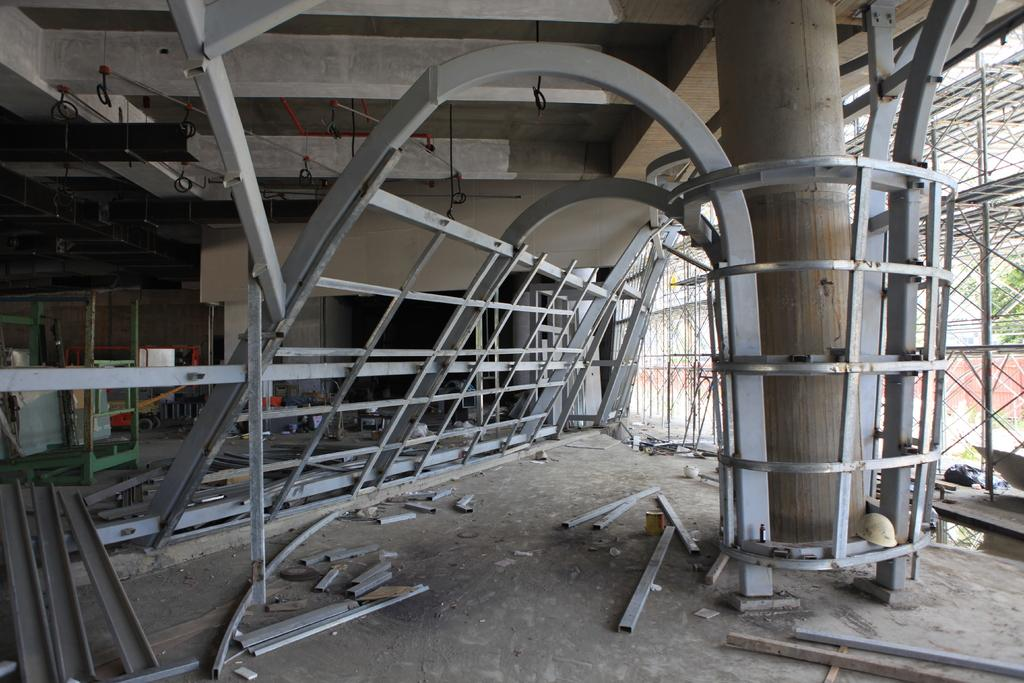What type of location is depicted in the image? The image is of a construction site. What structural elements can be seen at the construction site? There are beams and pillars visible in the image. What safety equipment is being used at the construction site? Helmets are visible in the image. What architectural features are present in the image? There is a ceiling and a wall in the image. What can be seen in the background of the image? Trees are present in the background of the image. What type of creature is crawling on the ceiling in the image? There is no creature crawling on the ceiling in the image; it is a construction site with a ceiling, but no creatures are present. 